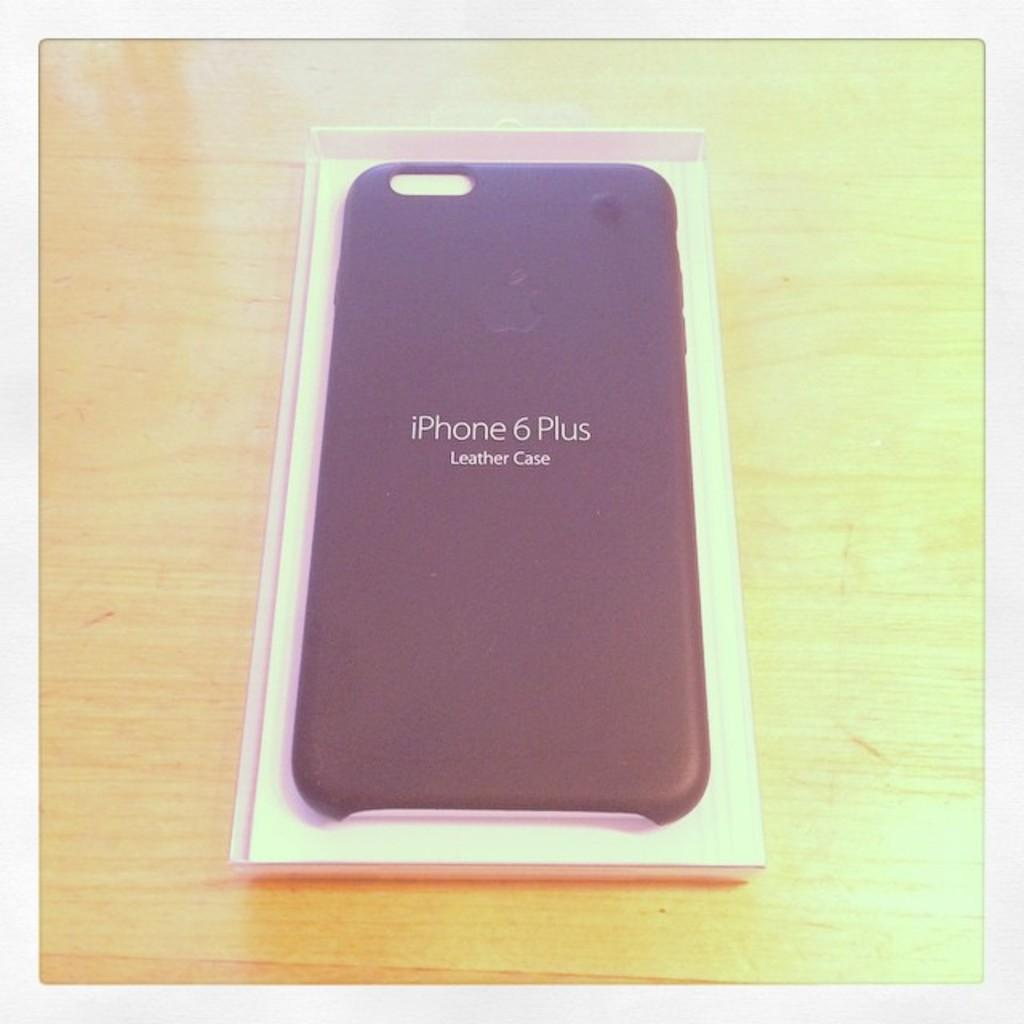<image>
Summarize the visual content of the image. An Iphone 6 Plus leather case rests on a wooden table. 